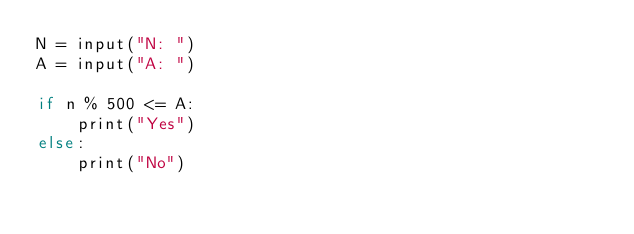<code> <loc_0><loc_0><loc_500><loc_500><_Julia_>N = input("N: ")
A = input("A: ")

if n % 500 <= A:
    print("Yes")
else:
    print("No")</code> 